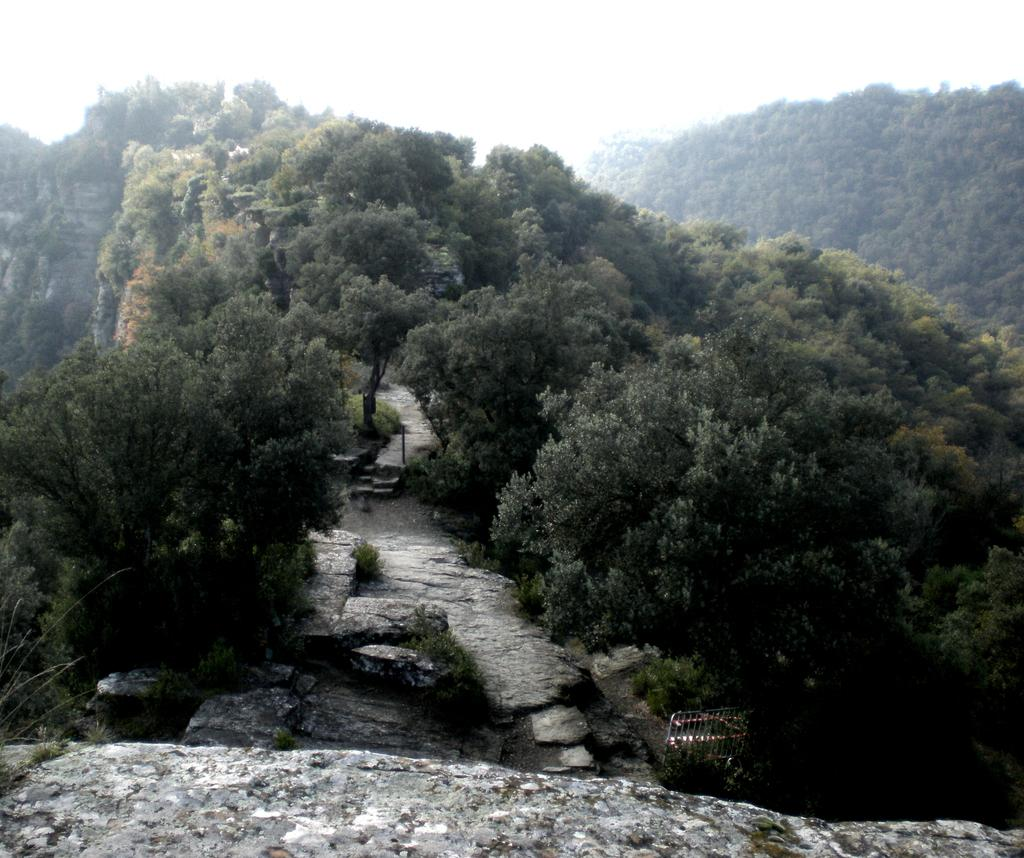What type of geological formation can be seen in the image? There are rock hills in the image. What type of vegetation is present in the image? There are trees in the image. What can be seen in the background of the image? The sky is visible in the background of the image. What type of plantation is visible in the image? There is no plantation present in the image; it features rock hills and trees. How does the coach affect the landscape in the image? There is no coach present in the image, so it cannot affect the landscape. 